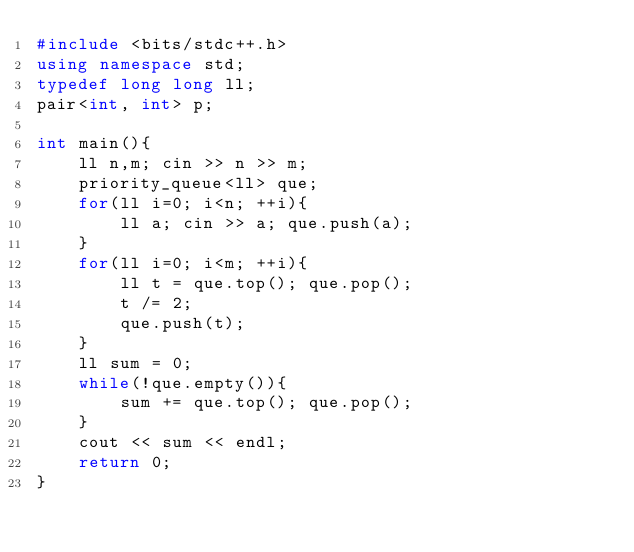<code> <loc_0><loc_0><loc_500><loc_500><_C++_>#include <bits/stdc++.h>
using namespace std;
typedef long long ll;
pair<int, int> p;

int main(){
    ll n,m; cin >> n >> m;
    priority_queue<ll> que;
    for(ll i=0; i<n; ++i){
        ll a; cin >> a; que.push(a);
    }
    for(ll i=0; i<m; ++i){
        ll t = que.top(); que.pop();
        t /= 2;
        que.push(t);
    }
    ll sum = 0;
    while(!que.empty()){
        sum += que.top(); que.pop();
    }
    cout << sum << endl;
    return 0;
}</code> 